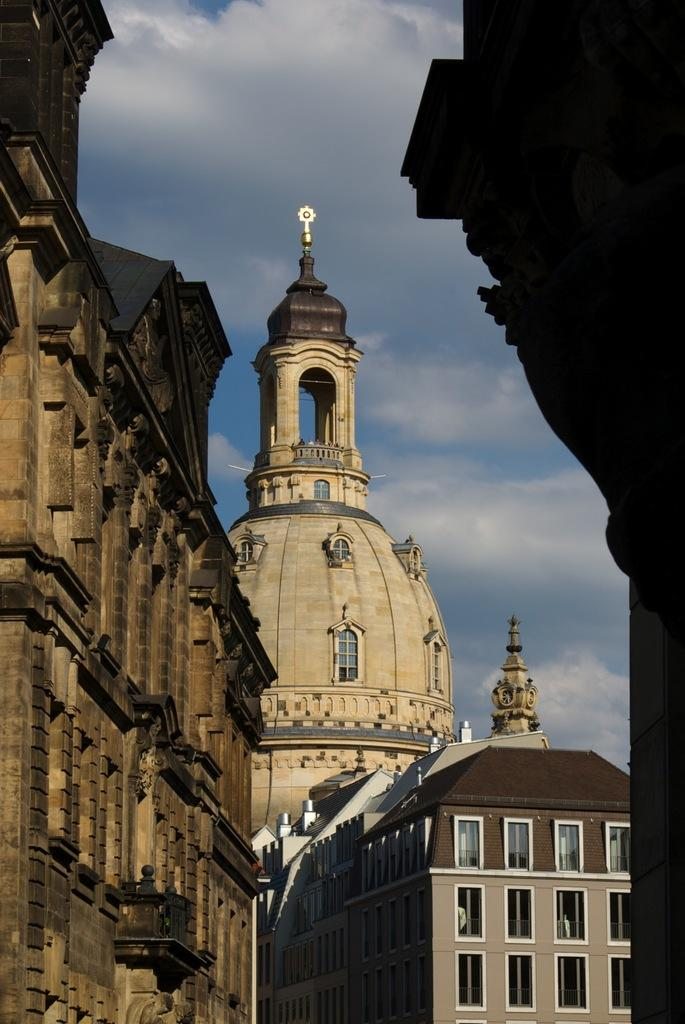What type of structures are present in the image? There are buildings with windows in the image. What can be seen above the buildings in the image? The sky is visible in the image. How would you describe the sky in the image? The sky appears to be cloudy. How many hats can be seen on the dolls in the image? There are no dolls or hats present in the image; it only features buildings and a cloudy sky. 